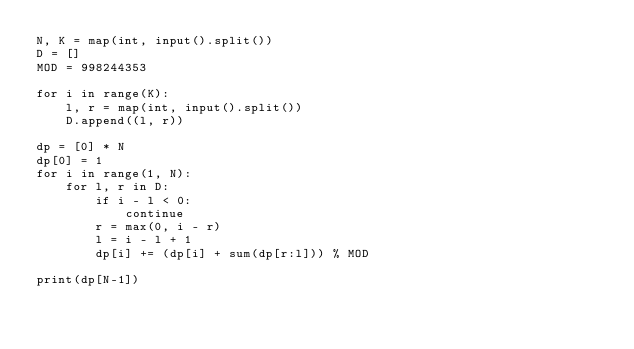<code> <loc_0><loc_0><loc_500><loc_500><_Python_>N, K = map(int, input().split())
D = []
MOD = 998244353

for i in range(K):
    l, r = map(int, input().split())
    D.append((l, r))

dp = [0] * N
dp[0] = 1
for i in range(1, N):
    for l, r in D:
        if i - l < 0:
            continue
        r = max(0, i - r)
        l = i - l + 1
        dp[i] += (dp[i] + sum(dp[r:l])) % MOD

print(dp[N-1])
</code> 